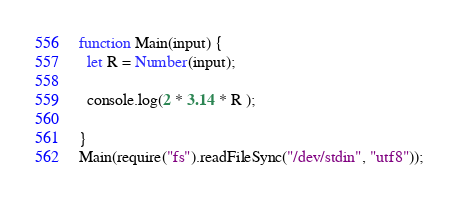<code> <loc_0><loc_0><loc_500><loc_500><_JavaScript_>function Main(input) {
  let R = Number(input);

  console.log(2 * 3.14 * R );

}
Main(require("fs").readFileSync("/dev/stdin", "utf8"));</code> 